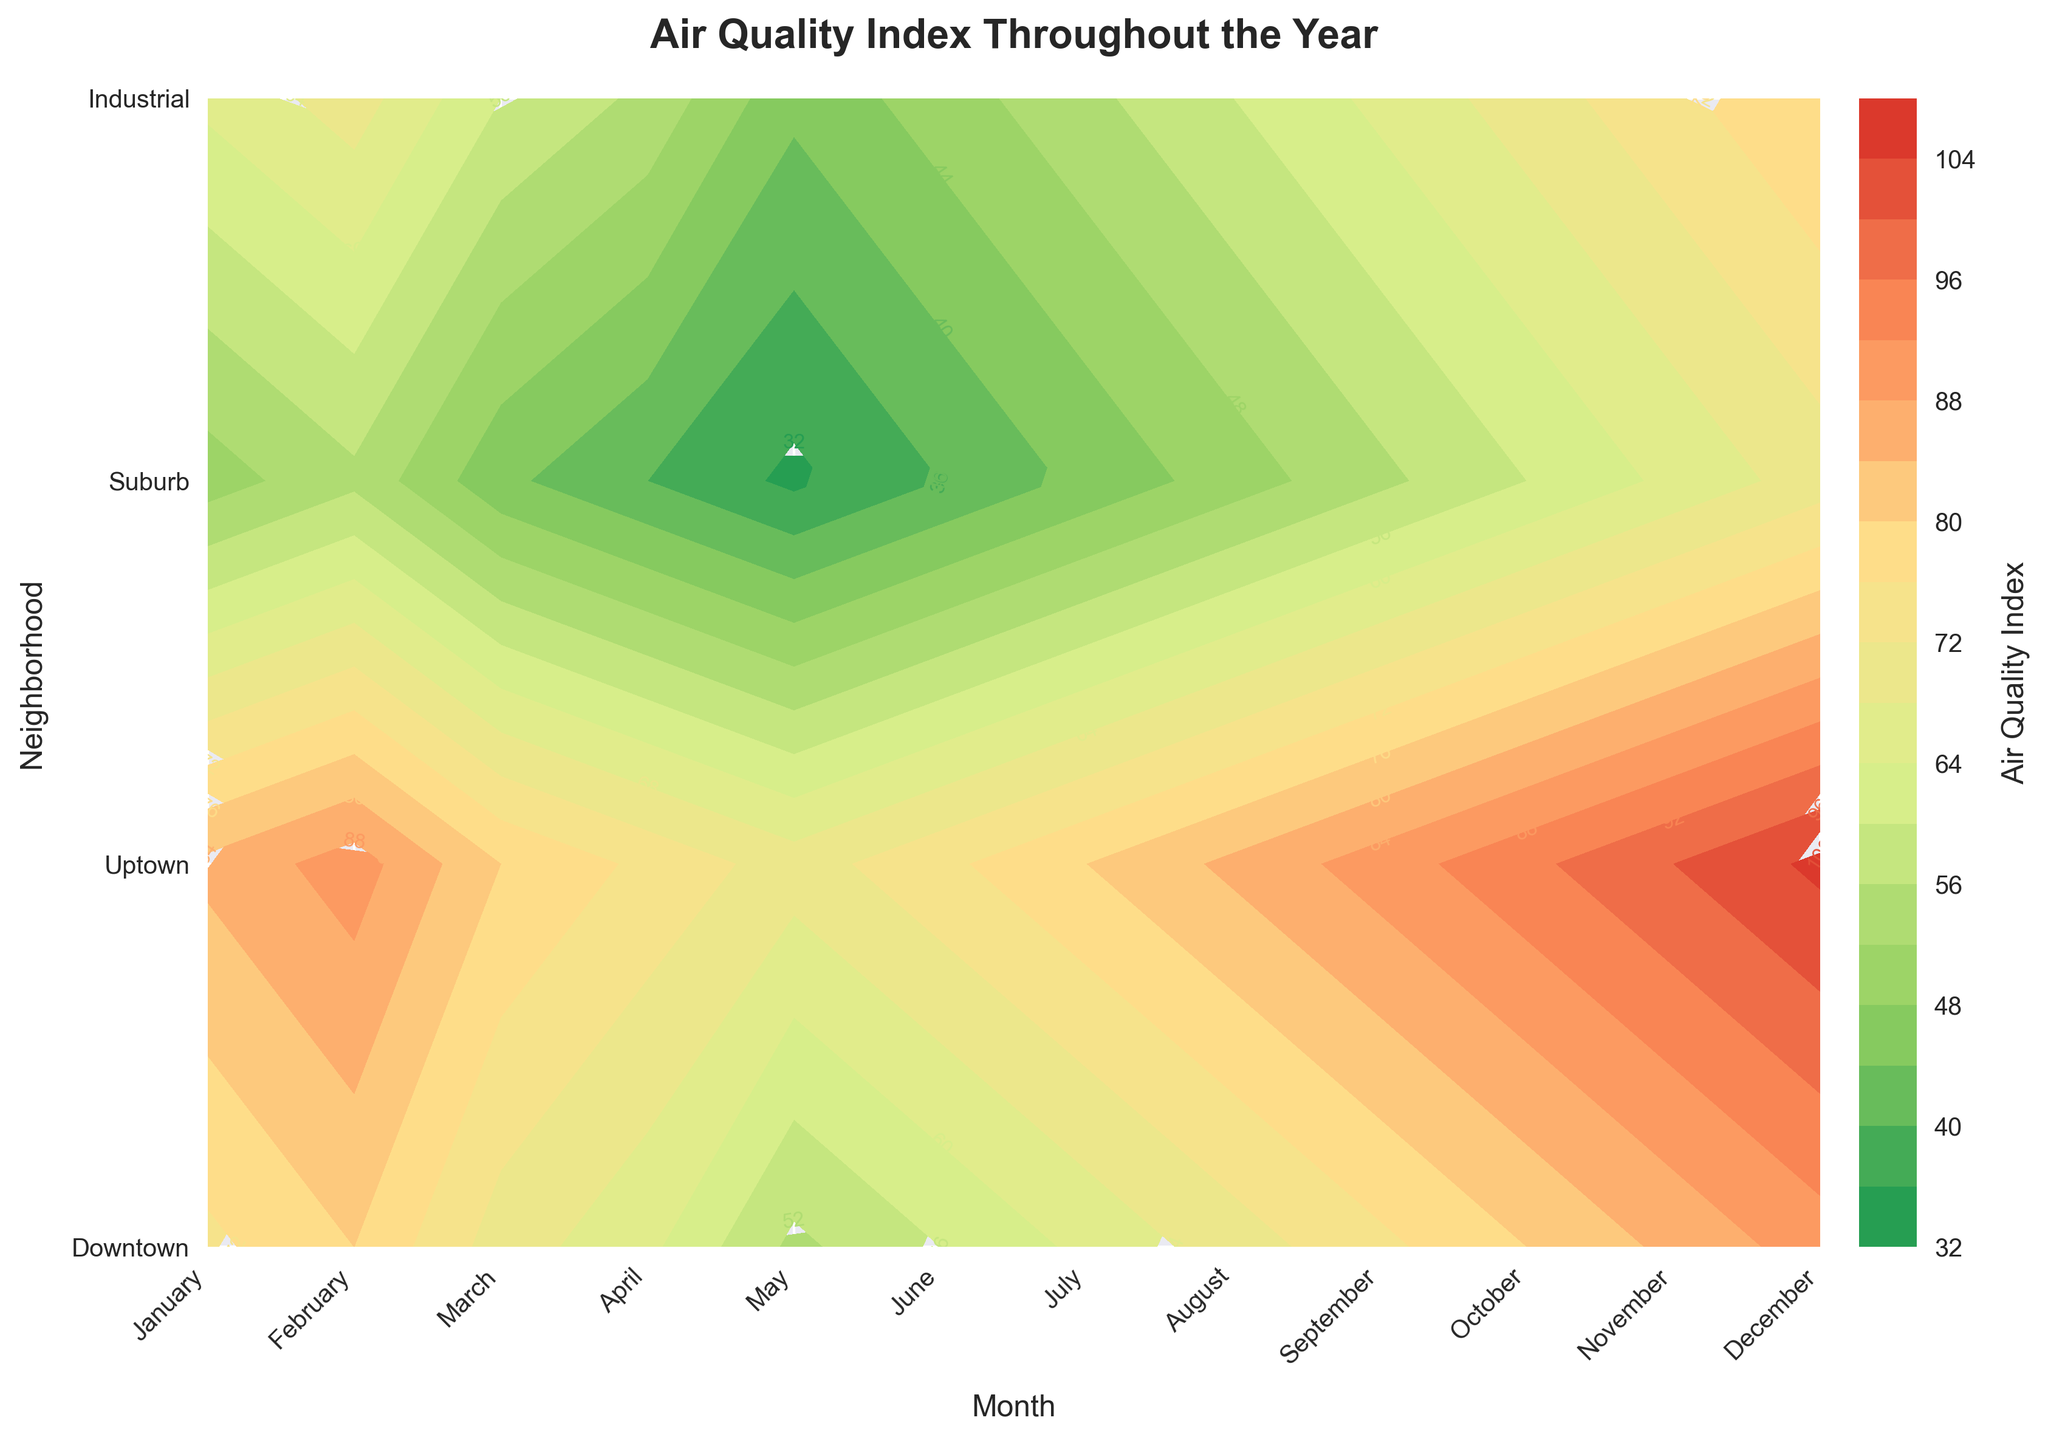What is the title of the plot? The title of the plot is usually placed at the top, and in this case, it clearly says 'Air Quality Index Throughout the Year'.
Answer: Air Quality Index Throughout the Year Which neighborhood has the highest air quality index in December? To find the highest air quality index in December, first locate the column for December and then identify the highest value within that column. The highest value is 105, which corresponds to the Industrial neighborhood.
Answer: Industrial How many neighborhoods are analyzed in this plot? The number of neighborhoods can be counted along the y-axis. There are four neighborhoods listed: Downtown, Uptown, Suburb, and Industrial.
Answer: Four In which month does Uptown have the lowest air quality index? To find the lowest air quality index for Uptown, look at the row corresponding to Uptown and find the minimum value. The lowest value in that row is 45, which occurs in May.
Answer: May Which month shows the highest air quality index for the Suburb neighborhood? To find the highest air quality index for Suburb, look along the corresponding Suburb row in the plot. The highest value in that row is 70, which occurs in December.
Answer: December What trend can you observe about the air quality index of the Industrial neighborhood throughout the year? By examining the Industrial row from January to December, it is noticeable that the air quality index is increasing over the months, starting at 85 in January and reaching 105 in December.
Answer: Increasing trend Which two neighborhoods have the closest average air quality index throughout the year? First, calculate the average air quality index for each neighborhood by summing their monthly values and dividing by 12. The averages are Downtown (72.5), Uptown (62.5), Suburb (50), Industrial (87.5). Comparing these averages, Downtown (72.5) and Uptown (62.5) are the closest.
Answer: Downtown and Uptown During which month is the difference in air quality index between Downtown and Suburb the greatest? Determine the difference for each month by subtracting Suburb's index from Downtown's. The differences are: 25, 25, 25, 25, 20, 20, 20, 20, 20, 20, 20, 20. The highest difference, 25, occurs in January, February, March, and April.
Answer: January to April 